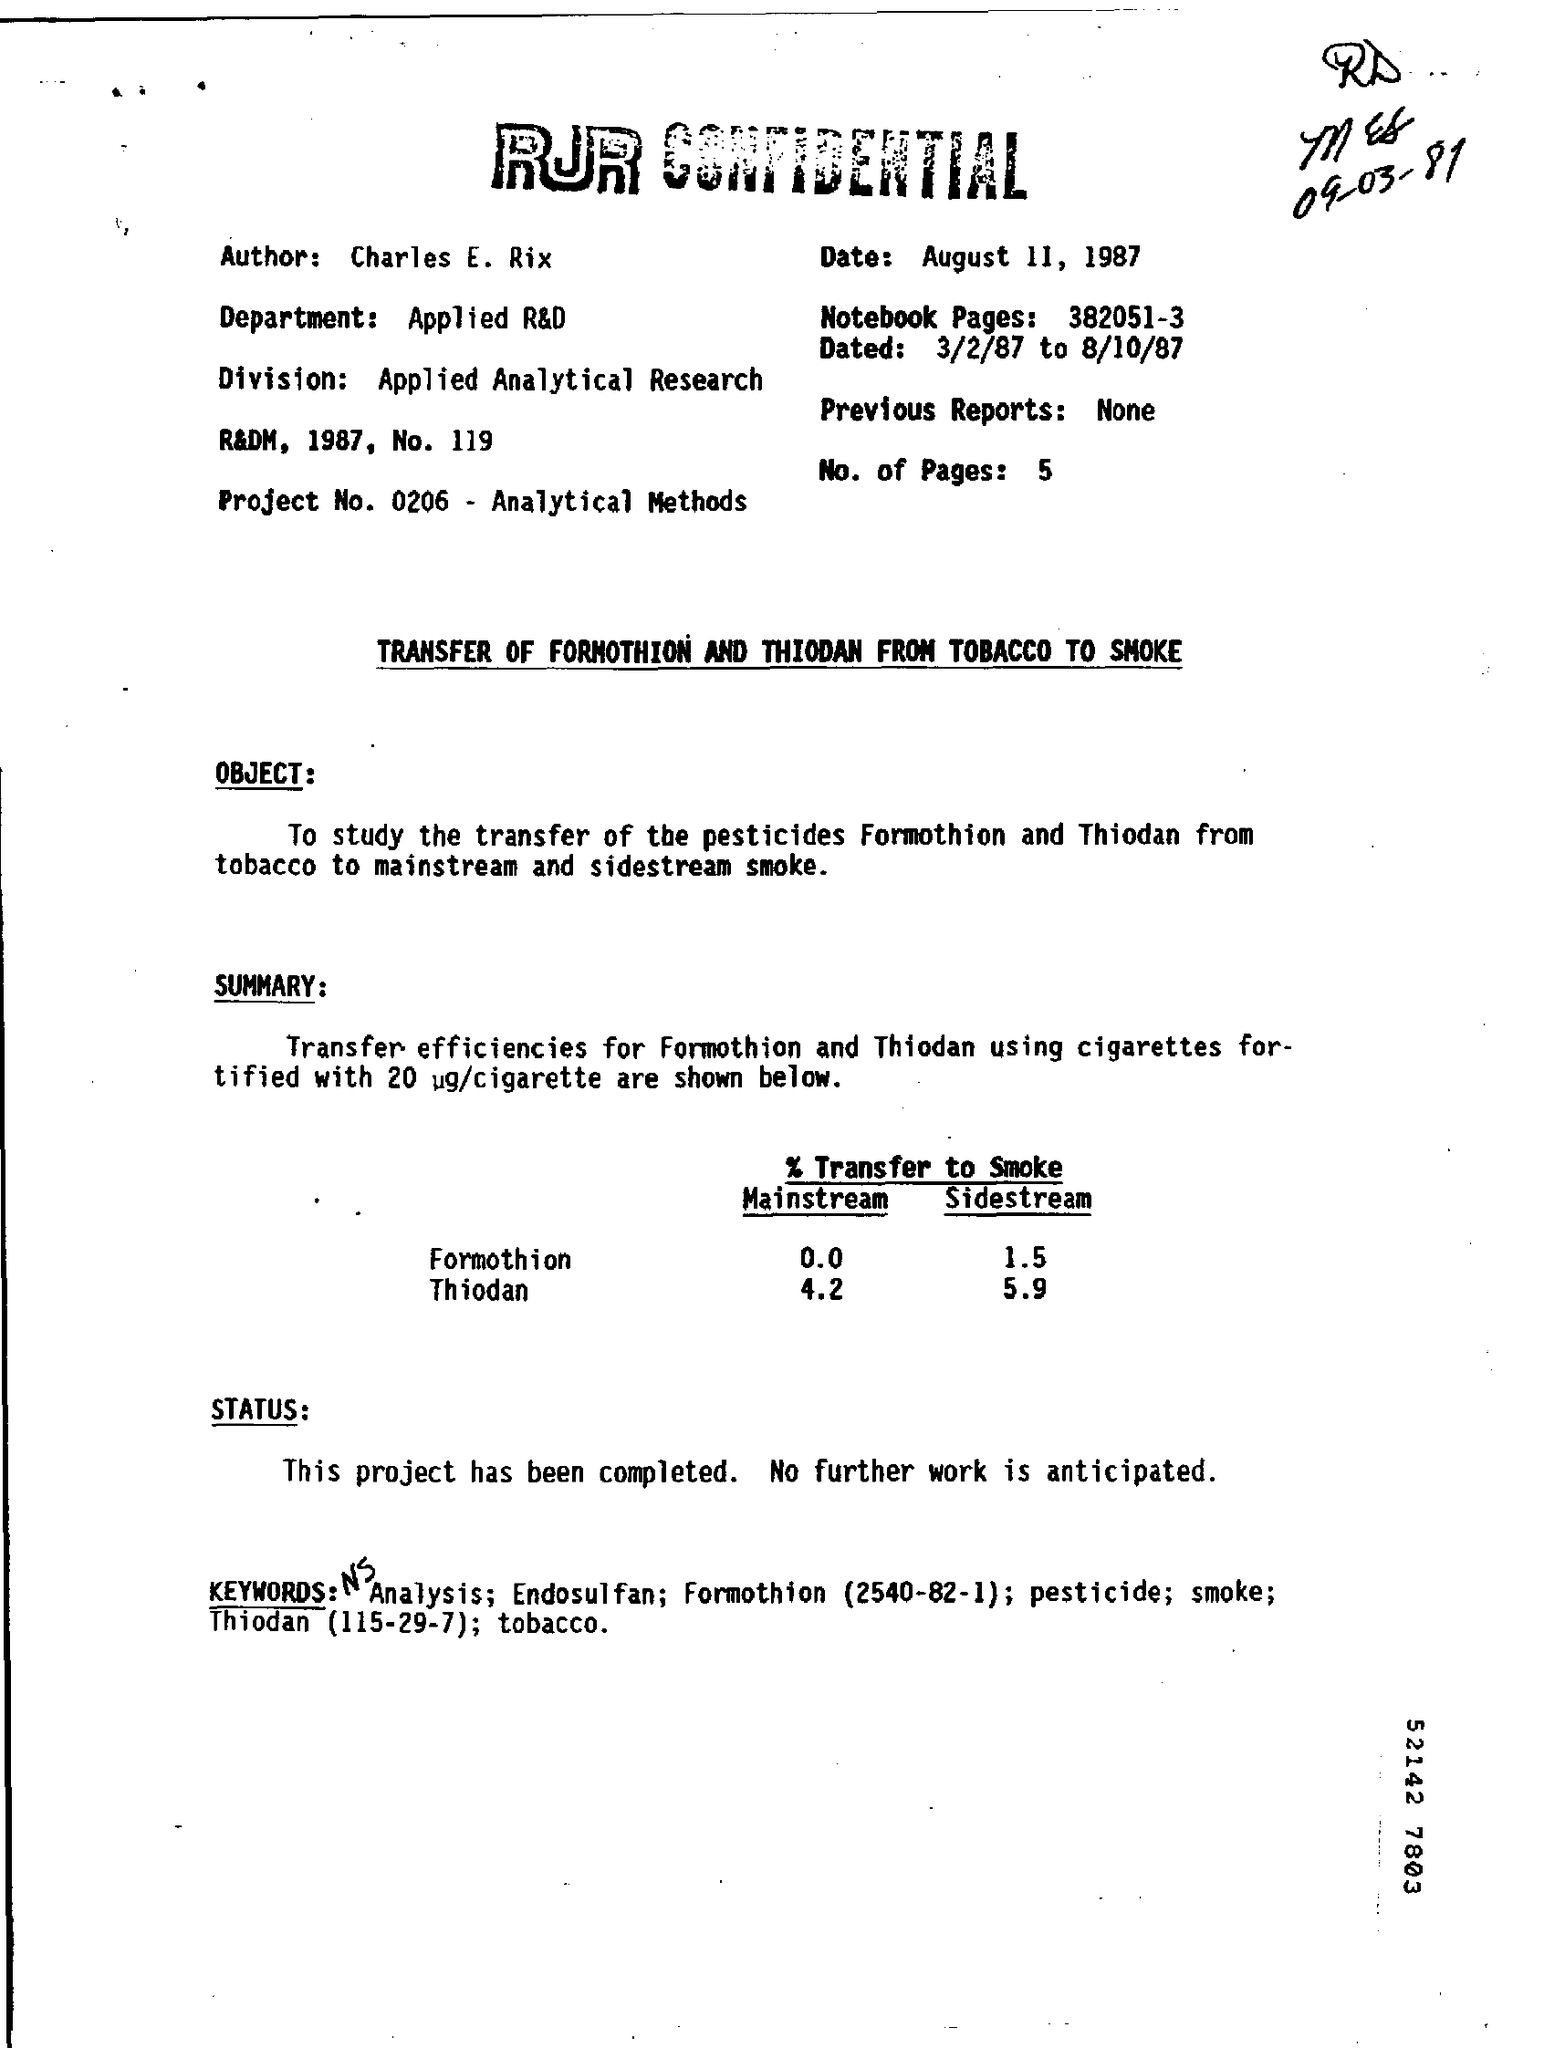What is the Author Name ?
Provide a short and direct response. Charles E. Rix. What is the Project Number ?
Give a very brief answer. 0206 - Analytical Methods. What is written in the Department Field ?
Your answer should be very brief. Applied R&D. What is written in the Division Field ?
Keep it short and to the point. Applied Analytical Research. 